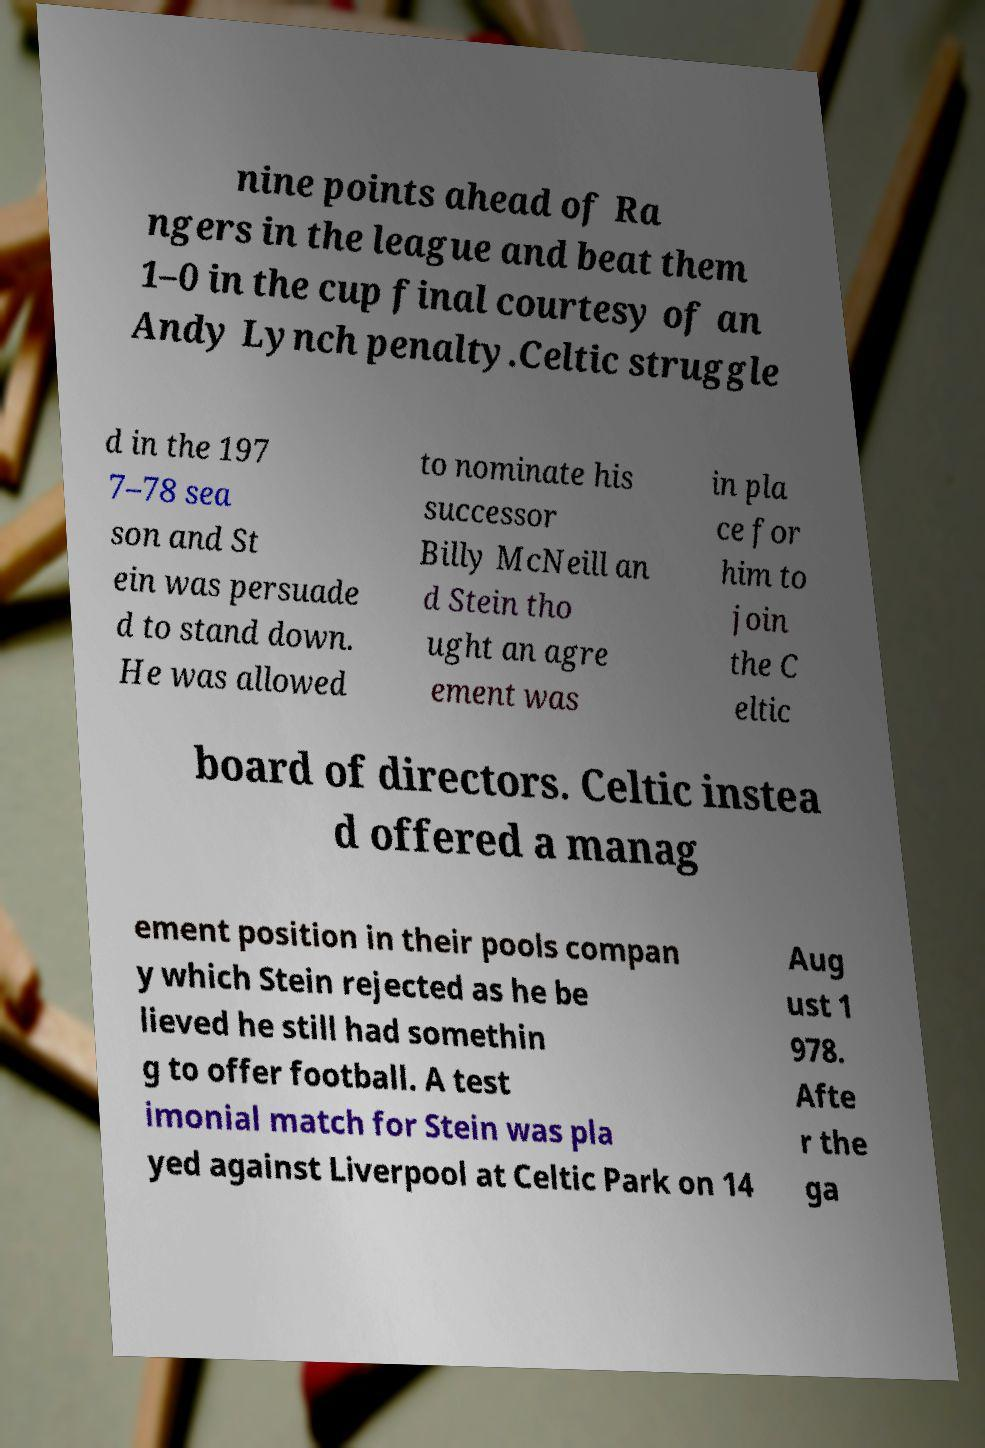Can you accurately transcribe the text from the provided image for me? nine points ahead of Ra ngers in the league and beat them 1–0 in the cup final courtesy of an Andy Lynch penalty.Celtic struggle d in the 197 7–78 sea son and St ein was persuade d to stand down. He was allowed to nominate his successor Billy McNeill an d Stein tho ught an agre ement was in pla ce for him to join the C eltic board of directors. Celtic instea d offered a manag ement position in their pools compan y which Stein rejected as he be lieved he still had somethin g to offer football. A test imonial match for Stein was pla yed against Liverpool at Celtic Park on 14 Aug ust 1 978. Afte r the ga 